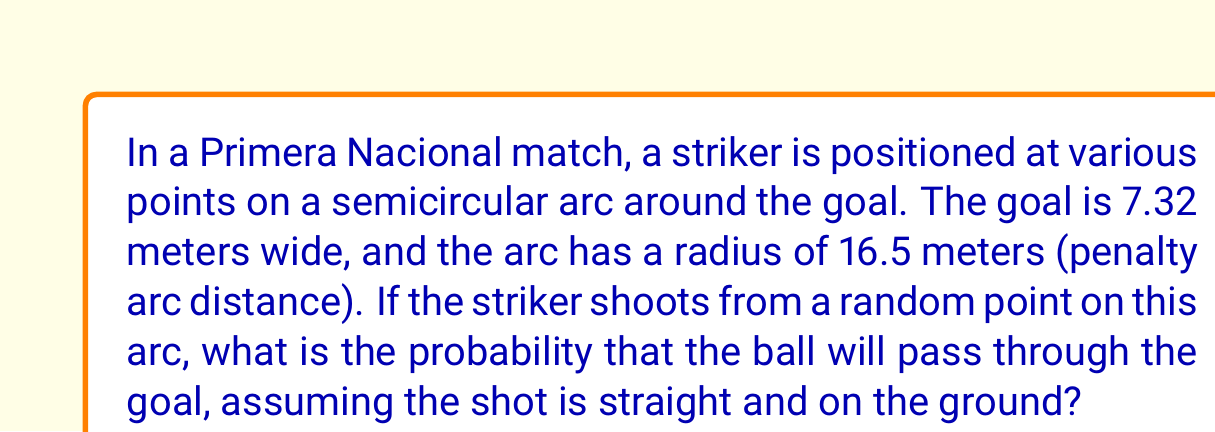Could you help me with this problem? Let's approach this step-by-step using geometric probability:

1) The probability is the ratio of the favorable outcomes to the total possible outcomes. In this case, it's the ratio of the angle subtended by the goal to the total angle of the semicircle.

2) Let's calculate the angle subtended by the goal:
   - The goal width is the chord of this angle.
   - We can use the formula: $\theta = 2 \arcsin(\frac{c}{2r})$
   Where $\theta$ is the central angle, $c$ is the chord length, and $r$ is the radius.

3) Substituting the values:
   $\theta = 2 \arcsin(\frac{7.32}{2 \cdot 16.5}) \approx 0.4458$ radians

4) The total angle of the semicircle is $\pi$ radians.

5) Therefore, the probability is:
   $$P = \frac{\theta}{\pi} = \frac{0.4458}{\pi} \approx 0.1419$$

6) Converting to a percentage:
   $0.1419 \cdot 100\% \approx 14.19\%$

[asy]
import geometry;

size(200);
draw(arc((0,0),16.5,0,180));
draw((-3.66,0)--(3.66,0),red);
draw((0,0)--(-3.66,0));
draw((0,0)--(3.66,0));
label("16.5m",(-8,8));
label("7.32m",(-1.83,-1));
[/asy]
Answer: 14.19% 